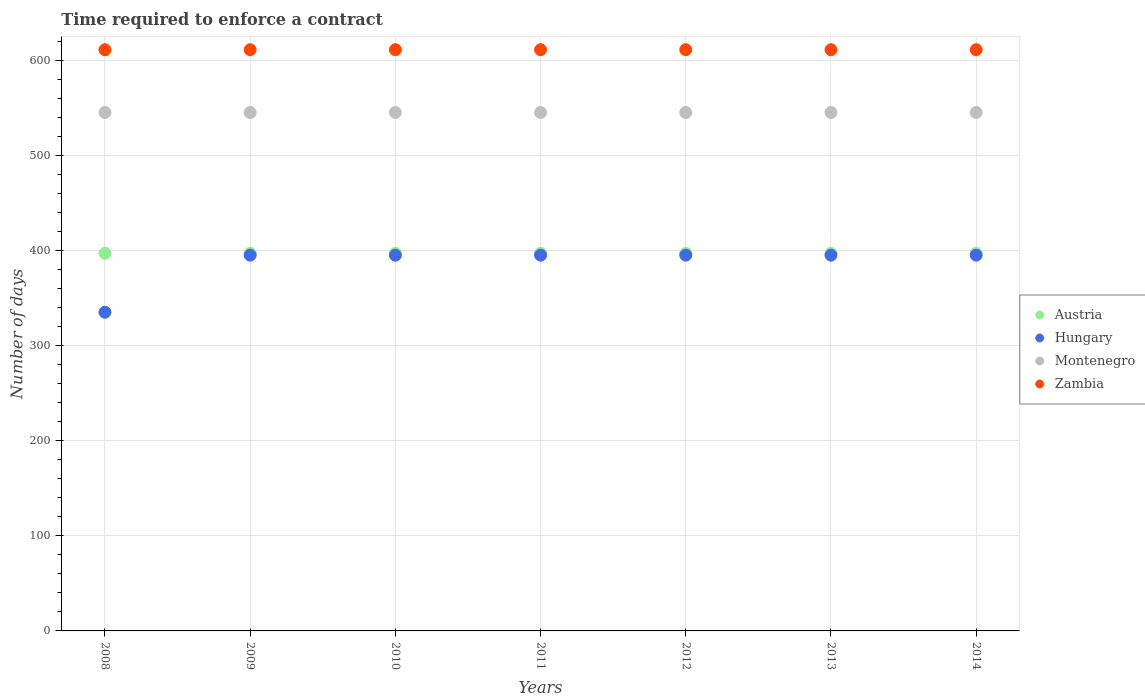What is the number of days required to enforce a contract in Austria in 2010?
Provide a short and direct response. 397. Across all years, what is the maximum number of days required to enforce a contract in Zambia?
Make the answer very short. 611. Across all years, what is the minimum number of days required to enforce a contract in Hungary?
Ensure brevity in your answer.  335. In which year was the number of days required to enforce a contract in Montenegro minimum?
Keep it short and to the point. 2008. What is the total number of days required to enforce a contract in Hungary in the graph?
Your answer should be compact. 2705. What is the difference between the number of days required to enforce a contract in Austria in 2014 and the number of days required to enforce a contract in Hungary in 2012?
Offer a terse response. 2. What is the average number of days required to enforce a contract in Hungary per year?
Your answer should be very brief. 386.43. In the year 2010, what is the difference between the number of days required to enforce a contract in Zambia and number of days required to enforce a contract in Hungary?
Keep it short and to the point. 216. What is the ratio of the number of days required to enforce a contract in Hungary in 2009 to that in 2013?
Provide a succinct answer. 1. Is the number of days required to enforce a contract in Austria in 2013 less than that in 2014?
Ensure brevity in your answer.  No. What is the difference between the highest and the second highest number of days required to enforce a contract in Hungary?
Ensure brevity in your answer.  0. What is the difference between the highest and the lowest number of days required to enforce a contract in Hungary?
Keep it short and to the point. 60. In how many years, is the number of days required to enforce a contract in Zambia greater than the average number of days required to enforce a contract in Zambia taken over all years?
Ensure brevity in your answer.  0. Is it the case that in every year, the sum of the number of days required to enforce a contract in Montenegro and number of days required to enforce a contract in Zambia  is greater than the number of days required to enforce a contract in Austria?
Offer a very short reply. Yes. Is the number of days required to enforce a contract in Austria strictly greater than the number of days required to enforce a contract in Hungary over the years?
Keep it short and to the point. Yes. Is the number of days required to enforce a contract in Zambia strictly less than the number of days required to enforce a contract in Hungary over the years?
Provide a short and direct response. No. How many years are there in the graph?
Your answer should be very brief. 7. Are the values on the major ticks of Y-axis written in scientific E-notation?
Keep it short and to the point. No. Does the graph contain any zero values?
Offer a terse response. No. Where does the legend appear in the graph?
Make the answer very short. Center right. What is the title of the graph?
Provide a succinct answer. Time required to enforce a contract. What is the label or title of the X-axis?
Provide a succinct answer. Years. What is the label or title of the Y-axis?
Provide a succinct answer. Number of days. What is the Number of days of Austria in 2008?
Make the answer very short. 397. What is the Number of days in Hungary in 2008?
Give a very brief answer. 335. What is the Number of days in Montenegro in 2008?
Ensure brevity in your answer.  545. What is the Number of days of Zambia in 2008?
Your answer should be compact. 611. What is the Number of days of Austria in 2009?
Offer a terse response. 397. What is the Number of days in Hungary in 2009?
Give a very brief answer. 395. What is the Number of days of Montenegro in 2009?
Offer a terse response. 545. What is the Number of days of Zambia in 2009?
Ensure brevity in your answer.  611. What is the Number of days in Austria in 2010?
Your response must be concise. 397. What is the Number of days of Hungary in 2010?
Offer a very short reply. 395. What is the Number of days in Montenegro in 2010?
Your response must be concise. 545. What is the Number of days of Zambia in 2010?
Offer a terse response. 611. What is the Number of days of Austria in 2011?
Your answer should be very brief. 397. What is the Number of days of Hungary in 2011?
Your answer should be compact. 395. What is the Number of days of Montenegro in 2011?
Keep it short and to the point. 545. What is the Number of days in Zambia in 2011?
Provide a succinct answer. 611. What is the Number of days in Austria in 2012?
Provide a short and direct response. 397. What is the Number of days in Hungary in 2012?
Provide a short and direct response. 395. What is the Number of days of Montenegro in 2012?
Make the answer very short. 545. What is the Number of days of Zambia in 2012?
Give a very brief answer. 611. What is the Number of days of Austria in 2013?
Your answer should be compact. 397. What is the Number of days of Hungary in 2013?
Give a very brief answer. 395. What is the Number of days in Montenegro in 2013?
Your response must be concise. 545. What is the Number of days of Zambia in 2013?
Offer a very short reply. 611. What is the Number of days in Austria in 2014?
Provide a succinct answer. 397. What is the Number of days in Hungary in 2014?
Give a very brief answer. 395. What is the Number of days in Montenegro in 2014?
Your answer should be compact. 545. What is the Number of days in Zambia in 2014?
Give a very brief answer. 611. Across all years, what is the maximum Number of days in Austria?
Ensure brevity in your answer.  397. Across all years, what is the maximum Number of days in Hungary?
Ensure brevity in your answer.  395. Across all years, what is the maximum Number of days in Montenegro?
Offer a very short reply. 545. Across all years, what is the maximum Number of days of Zambia?
Your answer should be very brief. 611. Across all years, what is the minimum Number of days of Austria?
Your answer should be very brief. 397. Across all years, what is the minimum Number of days of Hungary?
Provide a succinct answer. 335. Across all years, what is the minimum Number of days in Montenegro?
Offer a very short reply. 545. Across all years, what is the minimum Number of days of Zambia?
Ensure brevity in your answer.  611. What is the total Number of days in Austria in the graph?
Give a very brief answer. 2779. What is the total Number of days of Hungary in the graph?
Your answer should be compact. 2705. What is the total Number of days of Montenegro in the graph?
Provide a succinct answer. 3815. What is the total Number of days in Zambia in the graph?
Keep it short and to the point. 4277. What is the difference between the Number of days in Hungary in 2008 and that in 2009?
Keep it short and to the point. -60. What is the difference between the Number of days of Montenegro in 2008 and that in 2009?
Make the answer very short. 0. What is the difference between the Number of days of Zambia in 2008 and that in 2009?
Make the answer very short. 0. What is the difference between the Number of days in Hungary in 2008 and that in 2010?
Offer a very short reply. -60. What is the difference between the Number of days in Zambia in 2008 and that in 2010?
Provide a succinct answer. 0. What is the difference between the Number of days of Austria in 2008 and that in 2011?
Your response must be concise. 0. What is the difference between the Number of days in Hungary in 2008 and that in 2011?
Make the answer very short. -60. What is the difference between the Number of days of Montenegro in 2008 and that in 2011?
Offer a terse response. 0. What is the difference between the Number of days in Zambia in 2008 and that in 2011?
Keep it short and to the point. 0. What is the difference between the Number of days of Austria in 2008 and that in 2012?
Provide a succinct answer. 0. What is the difference between the Number of days in Hungary in 2008 and that in 2012?
Offer a terse response. -60. What is the difference between the Number of days in Austria in 2008 and that in 2013?
Provide a short and direct response. 0. What is the difference between the Number of days in Hungary in 2008 and that in 2013?
Make the answer very short. -60. What is the difference between the Number of days in Zambia in 2008 and that in 2013?
Your response must be concise. 0. What is the difference between the Number of days of Hungary in 2008 and that in 2014?
Give a very brief answer. -60. What is the difference between the Number of days in Zambia in 2008 and that in 2014?
Keep it short and to the point. 0. What is the difference between the Number of days in Montenegro in 2009 and that in 2010?
Offer a very short reply. 0. What is the difference between the Number of days in Zambia in 2009 and that in 2010?
Ensure brevity in your answer.  0. What is the difference between the Number of days of Austria in 2009 and that in 2011?
Provide a short and direct response. 0. What is the difference between the Number of days of Montenegro in 2009 and that in 2011?
Ensure brevity in your answer.  0. What is the difference between the Number of days of Hungary in 2009 and that in 2012?
Your answer should be very brief. 0. What is the difference between the Number of days in Montenegro in 2009 and that in 2012?
Make the answer very short. 0. What is the difference between the Number of days of Zambia in 2009 and that in 2012?
Provide a short and direct response. 0. What is the difference between the Number of days of Hungary in 2009 and that in 2013?
Offer a terse response. 0. What is the difference between the Number of days of Montenegro in 2009 and that in 2013?
Your response must be concise. 0. What is the difference between the Number of days of Austria in 2009 and that in 2014?
Offer a terse response. 0. What is the difference between the Number of days of Montenegro in 2009 and that in 2014?
Provide a succinct answer. 0. What is the difference between the Number of days of Austria in 2010 and that in 2011?
Make the answer very short. 0. What is the difference between the Number of days in Hungary in 2010 and that in 2012?
Your response must be concise. 0. What is the difference between the Number of days of Zambia in 2010 and that in 2012?
Give a very brief answer. 0. What is the difference between the Number of days in Austria in 2010 and that in 2013?
Offer a terse response. 0. What is the difference between the Number of days in Montenegro in 2010 and that in 2013?
Offer a terse response. 0. What is the difference between the Number of days in Zambia in 2010 and that in 2013?
Offer a very short reply. 0. What is the difference between the Number of days of Montenegro in 2010 and that in 2014?
Your answer should be compact. 0. What is the difference between the Number of days in Zambia in 2010 and that in 2014?
Your answer should be compact. 0. What is the difference between the Number of days in Austria in 2011 and that in 2012?
Keep it short and to the point. 0. What is the difference between the Number of days of Hungary in 2011 and that in 2013?
Give a very brief answer. 0. What is the difference between the Number of days in Zambia in 2011 and that in 2013?
Give a very brief answer. 0. What is the difference between the Number of days of Austria in 2011 and that in 2014?
Keep it short and to the point. 0. What is the difference between the Number of days of Hungary in 2011 and that in 2014?
Your answer should be very brief. 0. What is the difference between the Number of days of Zambia in 2011 and that in 2014?
Your response must be concise. 0. What is the difference between the Number of days of Hungary in 2012 and that in 2013?
Ensure brevity in your answer.  0. What is the difference between the Number of days in Montenegro in 2012 and that in 2013?
Offer a terse response. 0. What is the difference between the Number of days of Zambia in 2012 and that in 2013?
Keep it short and to the point. 0. What is the difference between the Number of days of Montenegro in 2012 and that in 2014?
Your response must be concise. 0. What is the difference between the Number of days of Zambia in 2012 and that in 2014?
Provide a short and direct response. 0. What is the difference between the Number of days in Zambia in 2013 and that in 2014?
Your answer should be very brief. 0. What is the difference between the Number of days in Austria in 2008 and the Number of days in Montenegro in 2009?
Ensure brevity in your answer.  -148. What is the difference between the Number of days of Austria in 2008 and the Number of days of Zambia in 2009?
Your answer should be compact. -214. What is the difference between the Number of days of Hungary in 2008 and the Number of days of Montenegro in 2009?
Your answer should be very brief. -210. What is the difference between the Number of days of Hungary in 2008 and the Number of days of Zambia in 2009?
Give a very brief answer. -276. What is the difference between the Number of days in Montenegro in 2008 and the Number of days in Zambia in 2009?
Offer a terse response. -66. What is the difference between the Number of days of Austria in 2008 and the Number of days of Montenegro in 2010?
Offer a terse response. -148. What is the difference between the Number of days in Austria in 2008 and the Number of days in Zambia in 2010?
Give a very brief answer. -214. What is the difference between the Number of days of Hungary in 2008 and the Number of days of Montenegro in 2010?
Provide a short and direct response. -210. What is the difference between the Number of days in Hungary in 2008 and the Number of days in Zambia in 2010?
Offer a very short reply. -276. What is the difference between the Number of days in Montenegro in 2008 and the Number of days in Zambia in 2010?
Ensure brevity in your answer.  -66. What is the difference between the Number of days in Austria in 2008 and the Number of days in Hungary in 2011?
Provide a short and direct response. 2. What is the difference between the Number of days of Austria in 2008 and the Number of days of Montenegro in 2011?
Your answer should be very brief. -148. What is the difference between the Number of days in Austria in 2008 and the Number of days in Zambia in 2011?
Make the answer very short. -214. What is the difference between the Number of days in Hungary in 2008 and the Number of days in Montenegro in 2011?
Your answer should be compact. -210. What is the difference between the Number of days in Hungary in 2008 and the Number of days in Zambia in 2011?
Ensure brevity in your answer.  -276. What is the difference between the Number of days of Montenegro in 2008 and the Number of days of Zambia in 2011?
Provide a succinct answer. -66. What is the difference between the Number of days of Austria in 2008 and the Number of days of Montenegro in 2012?
Your answer should be compact. -148. What is the difference between the Number of days in Austria in 2008 and the Number of days in Zambia in 2012?
Provide a succinct answer. -214. What is the difference between the Number of days in Hungary in 2008 and the Number of days in Montenegro in 2012?
Your response must be concise. -210. What is the difference between the Number of days of Hungary in 2008 and the Number of days of Zambia in 2012?
Your answer should be compact. -276. What is the difference between the Number of days of Montenegro in 2008 and the Number of days of Zambia in 2012?
Your response must be concise. -66. What is the difference between the Number of days of Austria in 2008 and the Number of days of Montenegro in 2013?
Your answer should be compact. -148. What is the difference between the Number of days in Austria in 2008 and the Number of days in Zambia in 2013?
Offer a very short reply. -214. What is the difference between the Number of days of Hungary in 2008 and the Number of days of Montenegro in 2013?
Provide a succinct answer. -210. What is the difference between the Number of days of Hungary in 2008 and the Number of days of Zambia in 2013?
Provide a short and direct response. -276. What is the difference between the Number of days of Montenegro in 2008 and the Number of days of Zambia in 2013?
Make the answer very short. -66. What is the difference between the Number of days in Austria in 2008 and the Number of days in Hungary in 2014?
Offer a terse response. 2. What is the difference between the Number of days of Austria in 2008 and the Number of days of Montenegro in 2014?
Provide a succinct answer. -148. What is the difference between the Number of days in Austria in 2008 and the Number of days in Zambia in 2014?
Ensure brevity in your answer.  -214. What is the difference between the Number of days of Hungary in 2008 and the Number of days of Montenegro in 2014?
Provide a short and direct response. -210. What is the difference between the Number of days of Hungary in 2008 and the Number of days of Zambia in 2014?
Provide a short and direct response. -276. What is the difference between the Number of days of Montenegro in 2008 and the Number of days of Zambia in 2014?
Offer a very short reply. -66. What is the difference between the Number of days in Austria in 2009 and the Number of days in Montenegro in 2010?
Offer a very short reply. -148. What is the difference between the Number of days in Austria in 2009 and the Number of days in Zambia in 2010?
Ensure brevity in your answer.  -214. What is the difference between the Number of days of Hungary in 2009 and the Number of days of Montenegro in 2010?
Make the answer very short. -150. What is the difference between the Number of days in Hungary in 2009 and the Number of days in Zambia in 2010?
Make the answer very short. -216. What is the difference between the Number of days of Montenegro in 2009 and the Number of days of Zambia in 2010?
Give a very brief answer. -66. What is the difference between the Number of days of Austria in 2009 and the Number of days of Hungary in 2011?
Provide a short and direct response. 2. What is the difference between the Number of days of Austria in 2009 and the Number of days of Montenegro in 2011?
Your answer should be compact. -148. What is the difference between the Number of days of Austria in 2009 and the Number of days of Zambia in 2011?
Your answer should be compact. -214. What is the difference between the Number of days of Hungary in 2009 and the Number of days of Montenegro in 2011?
Provide a short and direct response. -150. What is the difference between the Number of days in Hungary in 2009 and the Number of days in Zambia in 2011?
Ensure brevity in your answer.  -216. What is the difference between the Number of days in Montenegro in 2009 and the Number of days in Zambia in 2011?
Provide a short and direct response. -66. What is the difference between the Number of days of Austria in 2009 and the Number of days of Hungary in 2012?
Provide a succinct answer. 2. What is the difference between the Number of days in Austria in 2009 and the Number of days in Montenegro in 2012?
Provide a short and direct response. -148. What is the difference between the Number of days of Austria in 2009 and the Number of days of Zambia in 2012?
Your response must be concise. -214. What is the difference between the Number of days in Hungary in 2009 and the Number of days in Montenegro in 2012?
Make the answer very short. -150. What is the difference between the Number of days of Hungary in 2009 and the Number of days of Zambia in 2012?
Offer a very short reply. -216. What is the difference between the Number of days in Montenegro in 2009 and the Number of days in Zambia in 2012?
Provide a succinct answer. -66. What is the difference between the Number of days in Austria in 2009 and the Number of days in Hungary in 2013?
Provide a short and direct response. 2. What is the difference between the Number of days in Austria in 2009 and the Number of days in Montenegro in 2013?
Offer a terse response. -148. What is the difference between the Number of days in Austria in 2009 and the Number of days in Zambia in 2013?
Your answer should be compact. -214. What is the difference between the Number of days of Hungary in 2009 and the Number of days of Montenegro in 2013?
Ensure brevity in your answer.  -150. What is the difference between the Number of days of Hungary in 2009 and the Number of days of Zambia in 2013?
Provide a short and direct response. -216. What is the difference between the Number of days in Montenegro in 2009 and the Number of days in Zambia in 2013?
Offer a terse response. -66. What is the difference between the Number of days of Austria in 2009 and the Number of days of Montenegro in 2014?
Keep it short and to the point. -148. What is the difference between the Number of days in Austria in 2009 and the Number of days in Zambia in 2014?
Ensure brevity in your answer.  -214. What is the difference between the Number of days of Hungary in 2009 and the Number of days of Montenegro in 2014?
Provide a succinct answer. -150. What is the difference between the Number of days in Hungary in 2009 and the Number of days in Zambia in 2014?
Your response must be concise. -216. What is the difference between the Number of days of Montenegro in 2009 and the Number of days of Zambia in 2014?
Ensure brevity in your answer.  -66. What is the difference between the Number of days of Austria in 2010 and the Number of days of Montenegro in 2011?
Your answer should be very brief. -148. What is the difference between the Number of days in Austria in 2010 and the Number of days in Zambia in 2011?
Offer a very short reply. -214. What is the difference between the Number of days in Hungary in 2010 and the Number of days in Montenegro in 2011?
Your answer should be very brief. -150. What is the difference between the Number of days in Hungary in 2010 and the Number of days in Zambia in 2011?
Provide a succinct answer. -216. What is the difference between the Number of days in Montenegro in 2010 and the Number of days in Zambia in 2011?
Your answer should be compact. -66. What is the difference between the Number of days in Austria in 2010 and the Number of days in Hungary in 2012?
Offer a terse response. 2. What is the difference between the Number of days in Austria in 2010 and the Number of days in Montenegro in 2012?
Provide a succinct answer. -148. What is the difference between the Number of days in Austria in 2010 and the Number of days in Zambia in 2012?
Keep it short and to the point. -214. What is the difference between the Number of days in Hungary in 2010 and the Number of days in Montenegro in 2012?
Provide a succinct answer. -150. What is the difference between the Number of days in Hungary in 2010 and the Number of days in Zambia in 2012?
Your response must be concise. -216. What is the difference between the Number of days of Montenegro in 2010 and the Number of days of Zambia in 2012?
Ensure brevity in your answer.  -66. What is the difference between the Number of days in Austria in 2010 and the Number of days in Hungary in 2013?
Give a very brief answer. 2. What is the difference between the Number of days in Austria in 2010 and the Number of days in Montenegro in 2013?
Your answer should be compact. -148. What is the difference between the Number of days in Austria in 2010 and the Number of days in Zambia in 2013?
Your answer should be compact. -214. What is the difference between the Number of days of Hungary in 2010 and the Number of days of Montenegro in 2013?
Your answer should be compact. -150. What is the difference between the Number of days of Hungary in 2010 and the Number of days of Zambia in 2013?
Ensure brevity in your answer.  -216. What is the difference between the Number of days in Montenegro in 2010 and the Number of days in Zambia in 2013?
Provide a short and direct response. -66. What is the difference between the Number of days in Austria in 2010 and the Number of days in Hungary in 2014?
Offer a terse response. 2. What is the difference between the Number of days in Austria in 2010 and the Number of days in Montenegro in 2014?
Your response must be concise. -148. What is the difference between the Number of days of Austria in 2010 and the Number of days of Zambia in 2014?
Offer a very short reply. -214. What is the difference between the Number of days in Hungary in 2010 and the Number of days in Montenegro in 2014?
Offer a terse response. -150. What is the difference between the Number of days of Hungary in 2010 and the Number of days of Zambia in 2014?
Your answer should be very brief. -216. What is the difference between the Number of days in Montenegro in 2010 and the Number of days in Zambia in 2014?
Your answer should be very brief. -66. What is the difference between the Number of days of Austria in 2011 and the Number of days of Hungary in 2012?
Keep it short and to the point. 2. What is the difference between the Number of days in Austria in 2011 and the Number of days in Montenegro in 2012?
Provide a succinct answer. -148. What is the difference between the Number of days in Austria in 2011 and the Number of days in Zambia in 2012?
Provide a short and direct response. -214. What is the difference between the Number of days of Hungary in 2011 and the Number of days of Montenegro in 2012?
Keep it short and to the point. -150. What is the difference between the Number of days of Hungary in 2011 and the Number of days of Zambia in 2012?
Your response must be concise. -216. What is the difference between the Number of days in Montenegro in 2011 and the Number of days in Zambia in 2012?
Your answer should be compact. -66. What is the difference between the Number of days in Austria in 2011 and the Number of days in Montenegro in 2013?
Provide a short and direct response. -148. What is the difference between the Number of days of Austria in 2011 and the Number of days of Zambia in 2013?
Offer a terse response. -214. What is the difference between the Number of days of Hungary in 2011 and the Number of days of Montenegro in 2013?
Give a very brief answer. -150. What is the difference between the Number of days in Hungary in 2011 and the Number of days in Zambia in 2013?
Provide a short and direct response. -216. What is the difference between the Number of days in Montenegro in 2011 and the Number of days in Zambia in 2013?
Your answer should be very brief. -66. What is the difference between the Number of days of Austria in 2011 and the Number of days of Montenegro in 2014?
Your response must be concise. -148. What is the difference between the Number of days in Austria in 2011 and the Number of days in Zambia in 2014?
Give a very brief answer. -214. What is the difference between the Number of days in Hungary in 2011 and the Number of days in Montenegro in 2014?
Your answer should be very brief. -150. What is the difference between the Number of days of Hungary in 2011 and the Number of days of Zambia in 2014?
Your answer should be very brief. -216. What is the difference between the Number of days in Montenegro in 2011 and the Number of days in Zambia in 2014?
Provide a succinct answer. -66. What is the difference between the Number of days of Austria in 2012 and the Number of days of Hungary in 2013?
Your answer should be very brief. 2. What is the difference between the Number of days in Austria in 2012 and the Number of days in Montenegro in 2013?
Your response must be concise. -148. What is the difference between the Number of days of Austria in 2012 and the Number of days of Zambia in 2013?
Make the answer very short. -214. What is the difference between the Number of days of Hungary in 2012 and the Number of days of Montenegro in 2013?
Ensure brevity in your answer.  -150. What is the difference between the Number of days of Hungary in 2012 and the Number of days of Zambia in 2013?
Keep it short and to the point. -216. What is the difference between the Number of days of Montenegro in 2012 and the Number of days of Zambia in 2013?
Ensure brevity in your answer.  -66. What is the difference between the Number of days in Austria in 2012 and the Number of days in Montenegro in 2014?
Offer a terse response. -148. What is the difference between the Number of days of Austria in 2012 and the Number of days of Zambia in 2014?
Ensure brevity in your answer.  -214. What is the difference between the Number of days of Hungary in 2012 and the Number of days of Montenegro in 2014?
Your answer should be very brief. -150. What is the difference between the Number of days in Hungary in 2012 and the Number of days in Zambia in 2014?
Keep it short and to the point. -216. What is the difference between the Number of days in Montenegro in 2012 and the Number of days in Zambia in 2014?
Your answer should be compact. -66. What is the difference between the Number of days of Austria in 2013 and the Number of days of Montenegro in 2014?
Keep it short and to the point. -148. What is the difference between the Number of days of Austria in 2013 and the Number of days of Zambia in 2014?
Offer a very short reply. -214. What is the difference between the Number of days in Hungary in 2013 and the Number of days in Montenegro in 2014?
Give a very brief answer. -150. What is the difference between the Number of days in Hungary in 2013 and the Number of days in Zambia in 2014?
Make the answer very short. -216. What is the difference between the Number of days in Montenegro in 2013 and the Number of days in Zambia in 2014?
Ensure brevity in your answer.  -66. What is the average Number of days in Austria per year?
Offer a terse response. 397. What is the average Number of days in Hungary per year?
Provide a succinct answer. 386.43. What is the average Number of days in Montenegro per year?
Give a very brief answer. 545. What is the average Number of days of Zambia per year?
Ensure brevity in your answer.  611. In the year 2008, what is the difference between the Number of days of Austria and Number of days of Hungary?
Give a very brief answer. 62. In the year 2008, what is the difference between the Number of days in Austria and Number of days in Montenegro?
Provide a short and direct response. -148. In the year 2008, what is the difference between the Number of days of Austria and Number of days of Zambia?
Ensure brevity in your answer.  -214. In the year 2008, what is the difference between the Number of days in Hungary and Number of days in Montenegro?
Provide a succinct answer. -210. In the year 2008, what is the difference between the Number of days of Hungary and Number of days of Zambia?
Keep it short and to the point. -276. In the year 2008, what is the difference between the Number of days of Montenegro and Number of days of Zambia?
Your answer should be compact. -66. In the year 2009, what is the difference between the Number of days of Austria and Number of days of Montenegro?
Your answer should be compact. -148. In the year 2009, what is the difference between the Number of days in Austria and Number of days in Zambia?
Make the answer very short. -214. In the year 2009, what is the difference between the Number of days in Hungary and Number of days in Montenegro?
Provide a succinct answer. -150. In the year 2009, what is the difference between the Number of days of Hungary and Number of days of Zambia?
Give a very brief answer. -216. In the year 2009, what is the difference between the Number of days in Montenegro and Number of days in Zambia?
Offer a very short reply. -66. In the year 2010, what is the difference between the Number of days in Austria and Number of days in Montenegro?
Make the answer very short. -148. In the year 2010, what is the difference between the Number of days in Austria and Number of days in Zambia?
Your answer should be compact. -214. In the year 2010, what is the difference between the Number of days of Hungary and Number of days of Montenegro?
Your answer should be compact. -150. In the year 2010, what is the difference between the Number of days in Hungary and Number of days in Zambia?
Offer a very short reply. -216. In the year 2010, what is the difference between the Number of days in Montenegro and Number of days in Zambia?
Keep it short and to the point. -66. In the year 2011, what is the difference between the Number of days of Austria and Number of days of Montenegro?
Give a very brief answer. -148. In the year 2011, what is the difference between the Number of days of Austria and Number of days of Zambia?
Your answer should be very brief. -214. In the year 2011, what is the difference between the Number of days of Hungary and Number of days of Montenegro?
Your response must be concise. -150. In the year 2011, what is the difference between the Number of days of Hungary and Number of days of Zambia?
Provide a succinct answer. -216. In the year 2011, what is the difference between the Number of days in Montenegro and Number of days in Zambia?
Your answer should be very brief. -66. In the year 2012, what is the difference between the Number of days in Austria and Number of days in Montenegro?
Provide a short and direct response. -148. In the year 2012, what is the difference between the Number of days of Austria and Number of days of Zambia?
Ensure brevity in your answer.  -214. In the year 2012, what is the difference between the Number of days of Hungary and Number of days of Montenegro?
Your answer should be very brief. -150. In the year 2012, what is the difference between the Number of days of Hungary and Number of days of Zambia?
Make the answer very short. -216. In the year 2012, what is the difference between the Number of days of Montenegro and Number of days of Zambia?
Make the answer very short. -66. In the year 2013, what is the difference between the Number of days of Austria and Number of days of Hungary?
Keep it short and to the point. 2. In the year 2013, what is the difference between the Number of days of Austria and Number of days of Montenegro?
Provide a succinct answer. -148. In the year 2013, what is the difference between the Number of days of Austria and Number of days of Zambia?
Give a very brief answer. -214. In the year 2013, what is the difference between the Number of days in Hungary and Number of days in Montenegro?
Make the answer very short. -150. In the year 2013, what is the difference between the Number of days of Hungary and Number of days of Zambia?
Ensure brevity in your answer.  -216. In the year 2013, what is the difference between the Number of days of Montenegro and Number of days of Zambia?
Offer a terse response. -66. In the year 2014, what is the difference between the Number of days in Austria and Number of days in Hungary?
Keep it short and to the point. 2. In the year 2014, what is the difference between the Number of days in Austria and Number of days in Montenegro?
Keep it short and to the point. -148. In the year 2014, what is the difference between the Number of days of Austria and Number of days of Zambia?
Offer a very short reply. -214. In the year 2014, what is the difference between the Number of days in Hungary and Number of days in Montenegro?
Make the answer very short. -150. In the year 2014, what is the difference between the Number of days of Hungary and Number of days of Zambia?
Give a very brief answer. -216. In the year 2014, what is the difference between the Number of days of Montenegro and Number of days of Zambia?
Provide a short and direct response. -66. What is the ratio of the Number of days of Hungary in 2008 to that in 2009?
Keep it short and to the point. 0.85. What is the ratio of the Number of days of Hungary in 2008 to that in 2010?
Offer a very short reply. 0.85. What is the ratio of the Number of days in Montenegro in 2008 to that in 2010?
Give a very brief answer. 1. What is the ratio of the Number of days of Zambia in 2008 to that in 2010?
Provide a succinct answer. 1. What is the ratio of the Number of days of Hungary in 2008 to that in 2011?
Provide a short and direct response. 0.85. What is the ratio of the Number of days of Zambia in 2008 to that in 2011?
Your answer should be compact. 1. What is the ratio of the Number of days of Austria in 2008 to that in 2012?
Your answer should be compact. 1. What is the ratio of the Number of days of Hungary in 2008 to that in 2012?
Offer a terse response. 0.85. What is the ratio of the Number of days in Montenegro in 2008 to that in 2012?
Provide a succinct answer. 1. What is the ratio of the Number of days of Austria in 2008 to that in 2013?
Offer a very short reply. 1. What is the ratio of the Number of days in Hungary in 2008 to that in 2013?
Provide a succinct answer. 0.85. What is the ratio of the Number of days of Montenegro in 2008 to that in 2013?
Provide a short and direct response. 1. What is the ratio of the Number of days of Austria in 2008 to that in 2014?
Offer a very short reply. 1. What is the ratio of the Number of days of Hungary in 2008 to that in 2014?
Your response must be concise. 0.85. What is the ratio of the Number of days in Montenegro in 2008 to that in 2014?
Keep it short and to the point. 1. What is the ratio of the Number of days of Austria in 2009 to that in 2010?
Keep it short and to the point. 1. What is the ratio of the Number of days in Hungary in 2009 to that in 2010?
Ensure brevity in your answer.  1. What is the ratio of the Number of days in Montenegro in 2009 to that in 2010?
Give a very brief answer. 1. What is the ratio of the Number of days of Zambia in 2009 to that in 2010?
Offer a very short reply. 1. What is the ratio of the Number of days of Hungary in 2009 to that in 2011?
Offer a terse response. 1. What is the ratio of the Number of days in Zambia in 2009 to that in 2011?
Your response must be concise. 1. What is the ratio of the Number of days of Hungary in 2009 to that in 2012?
Offer a very short reply. 1. What is the ratio of the Number of days of Montenegro in 2009 to that in 2012?
Ensure brevity in your answer.  1. What is the ratio of the Number of days of Zambia in 2009 to that in 2013?
Make the answer very short. 1. What is the ratio of the Number of days in Austria in 2009 to that in 2014?
Keep it short and to the point. 1. What is the ratio of the Number of days of Zambia in 2009 to that in 2014?
Make the answer very short. 1. What is the ratio of the Number of days in Hungary in 2010 to that in 2011?
Provide a short and direct response. 1. What is the ratio of the Number of days of Zambia in 2010 to that in 2012?
Provide a succinct answer. 1. What is the ratio of the Number of days of Zambia in 2010 to that in 2013?
Your answer should be very brief. 1. What is the ratio of the Number of days of Austria in 2010 to that in 2014?
Give a very brief answer. 1. What is the ratio of the Number of days of Hungary in 2010 to that in 2014?
Offer a very short reply. 1. What is the ratio of the Number of days of Austria in 2011 to that in 2012?
Ensure brevity in your answer.  1. What is the ratio of the Number of days in Hungary in 2011 to that in 2013?
Provide a short and direct response. 1. What is the ratio of the Number of days in Montenegro in 2011 to that in 2013?
Make the answer very short. 1. What is the ratio of the Number of days of Hungary in 2011 to that in 2014?
Your answer should be compact. 1. What is the ratio of the Number of days of Montenegro in 2011 to that in 2014?
Give a very brief answer. 1. What is the ratio of the Number of days of Zambia in 2012 to that in 2013?
Make the answer very short. 1. What is the ratio of the Number of days of Hungary in 2012 to that in 2014?
Ensure brevity in your answer.  1. What is the ratio of the Number of days of Zambia in 2012 to that in 2014?
Your response must be concise. 1. What is the difference between the highest and the second highest Number of days of Montenegro?
Ensure brevity in your answer.  0. What is the difference between the highest and the lowest Number of days of Hungary?
Ensure brevity in your answer.  60. 